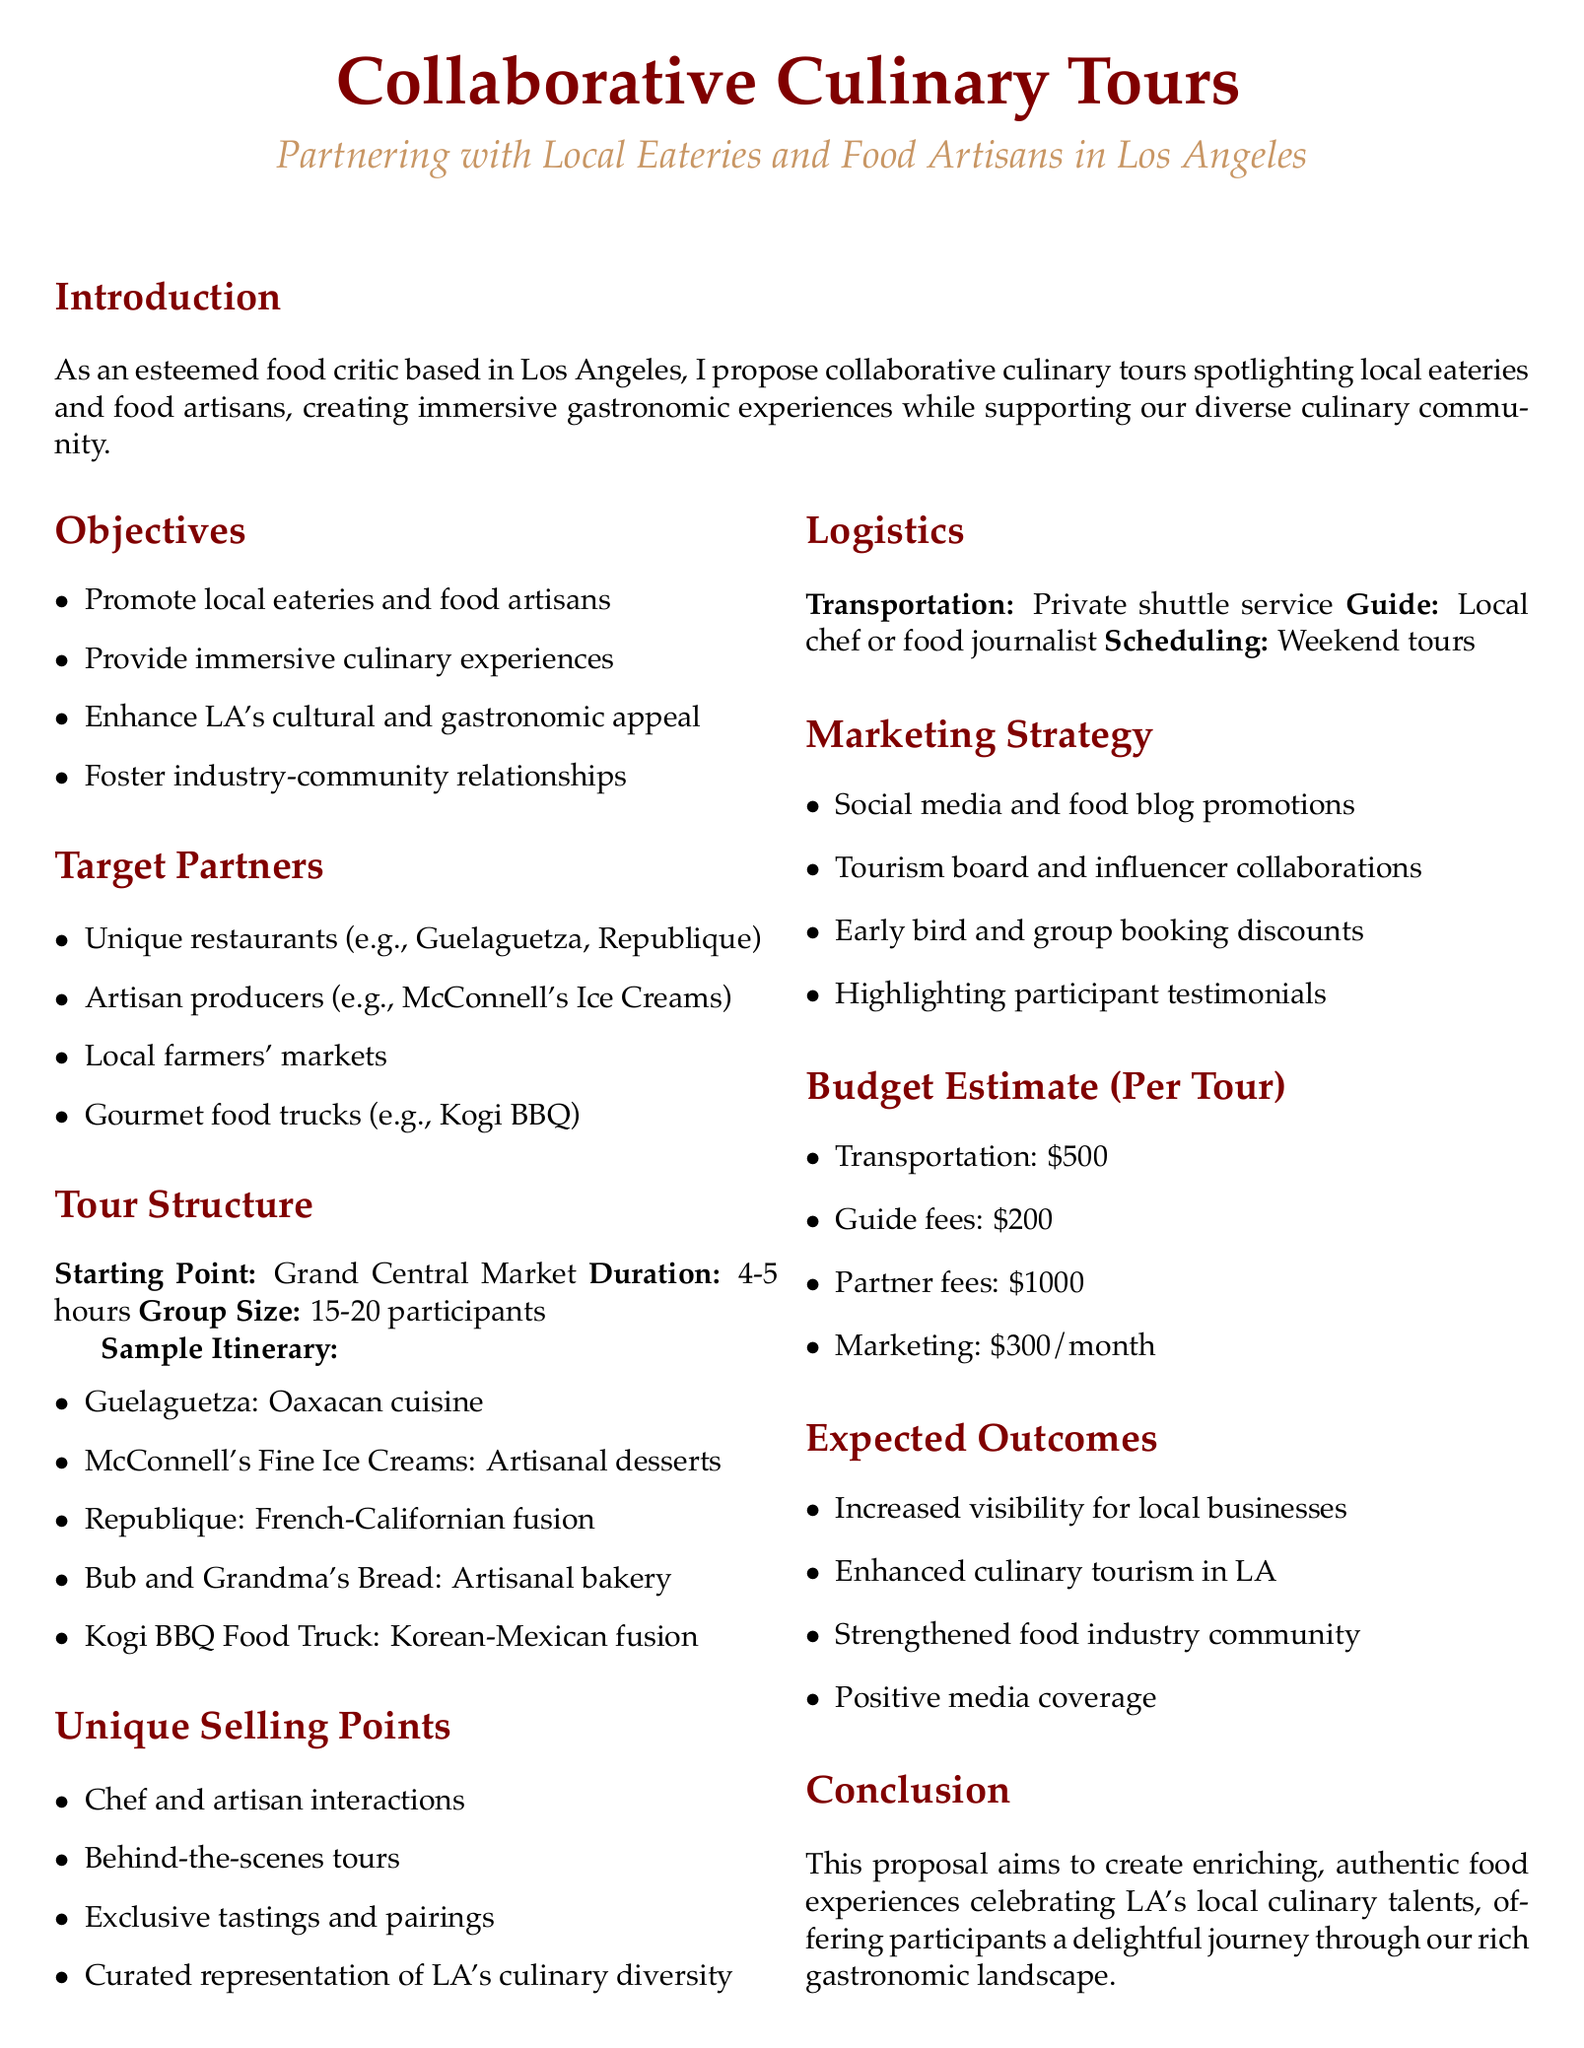What is the duration of the tours? The duration of the tours is mentioned as 4-5 hours in the document.
Answer: 4-5 hours Who are the unique restaurants listed as target partners? The target partners section lists specific restaurants as examples, including Guelaguetza and Republique.
Answer: Guelaguetza, Republique What type of cuisine does McConnell's Fine Ice Creams offer? McConnell's Fine Ice Creams is noted for artisanal desserts in the sample itinerary.
Answer: Artisanal desserts What is the transportation method proposed for the tours? The logistics section specifies that a private shuttle service will be used for transportation.
Answer: Private shuttle service What is the estimated cost for partner fees per tour? The budget estimate section mentions that the partner fees amount to $1000 for each tour.
Answer: $1000 How many participants are expected per tour? The document states that the group size for the tours is 15-20 participants.
Answer: 15-20 participants What is one unique selling point of the collaborative culinary tours? The unique selling points section highlights several features, like chef and artisan interactions.
Answer: Chef and artisan interactions What is the proposed marketing strategy element regarding testimonials? The marketing strategy includes highlighting participant testimonials among its promotional actions.
Answer: Highlighting participant testimonials How often are tours scheduled according to the logistics? The logistics section specifies that the tours are scheduled for weekends.
Answer: Weekend tours 